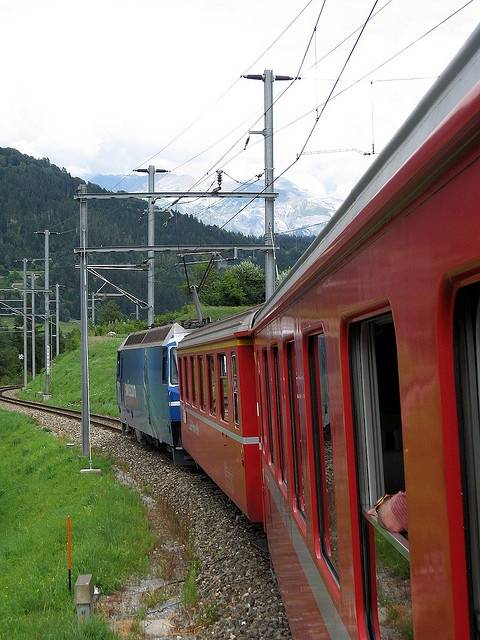Describe the objects in this image and their specific colors. I can see train in white, maroon, black, and gray tones and people in white, brown, and maroon tones in this image. 